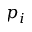<formula> <loc_0><loc_0><loc_500><loc_500>p _ { i }</formula> 